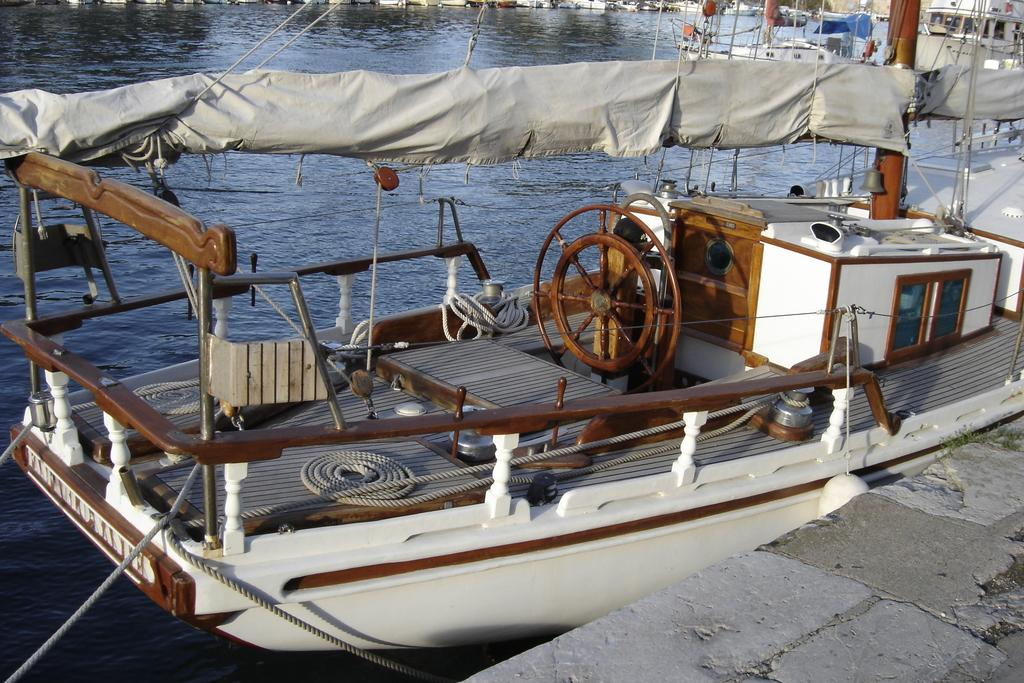What type of vehicles can be seen in the water in the image? There are boats in the water in the image. What object is present that might be used for tying or securing something? There is a rope in the image. What feature is visible that might be used for controlling the direction of the boats? There is a steering mechanism in the image. What natural element is visible in the image? There is water visible in the image. What type of material is present in the image? There is cloth in the image. What architectural feature is visible in the image? There is a window in the image. What month is depicted on the map in the image? There is no map present in the image, so it is not possible to determine the month. What type of tray is visible in the image? There is no tray present in the image. 